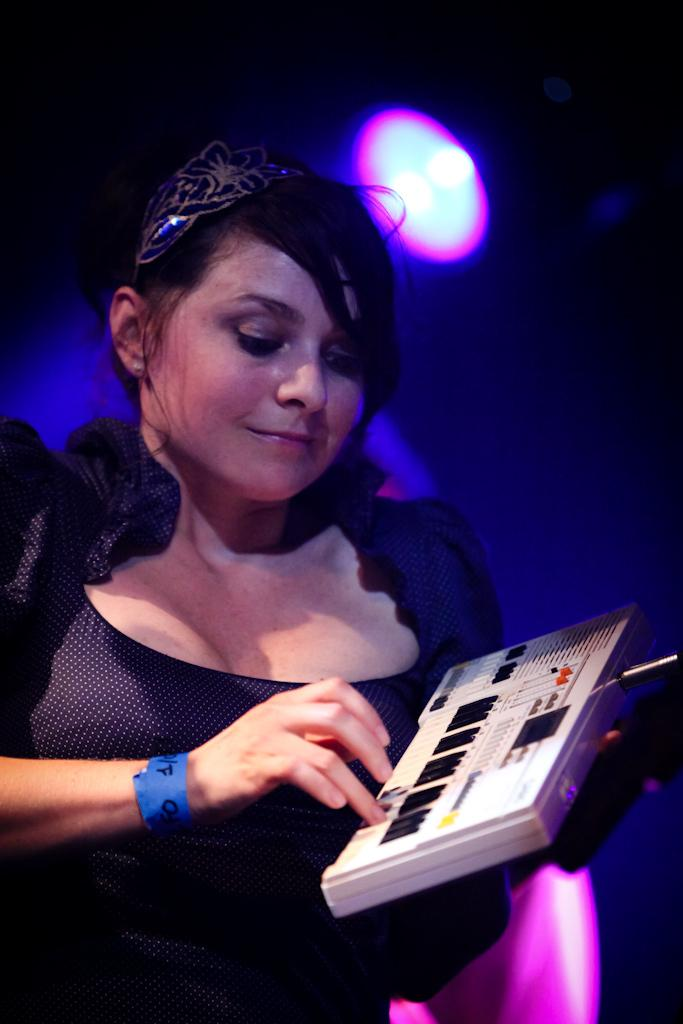Who is the main subject in the image? There is a woman in the image. What is the woman wearing? The woman is wearing a black dress. What is the woman doing in the image? The woman is playing a musical instrument. What can be seen near the ceiling in the image? There is a light visible near the ceiling in the image. What knowledge does the woman possess about the cause of throat infections in the image? There is no information about throat infections or the woman's knowledge in the image. 